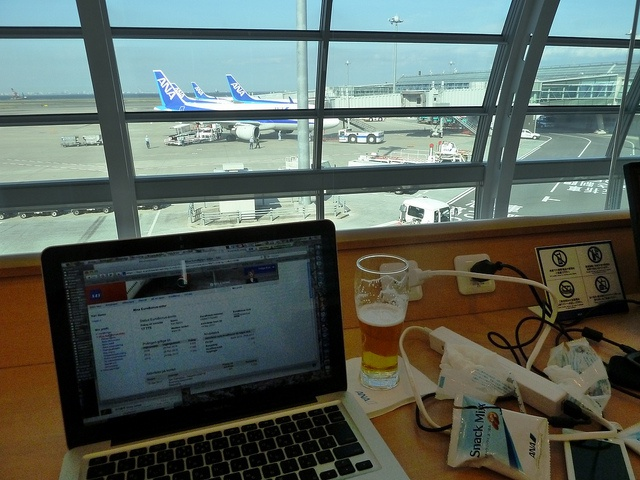Describe the objects in this image and their specific colors. I can see laptop in lightblue, black, gray, blue, and darkblue tones, cup in lightblue, gray, maroon, and olive tones, cell phone in lightblue, black, gray, and darkgreen tones, airplane in lightblue and white tones, and truck in lightblue, white, teal, and darkgray tones in this image. 